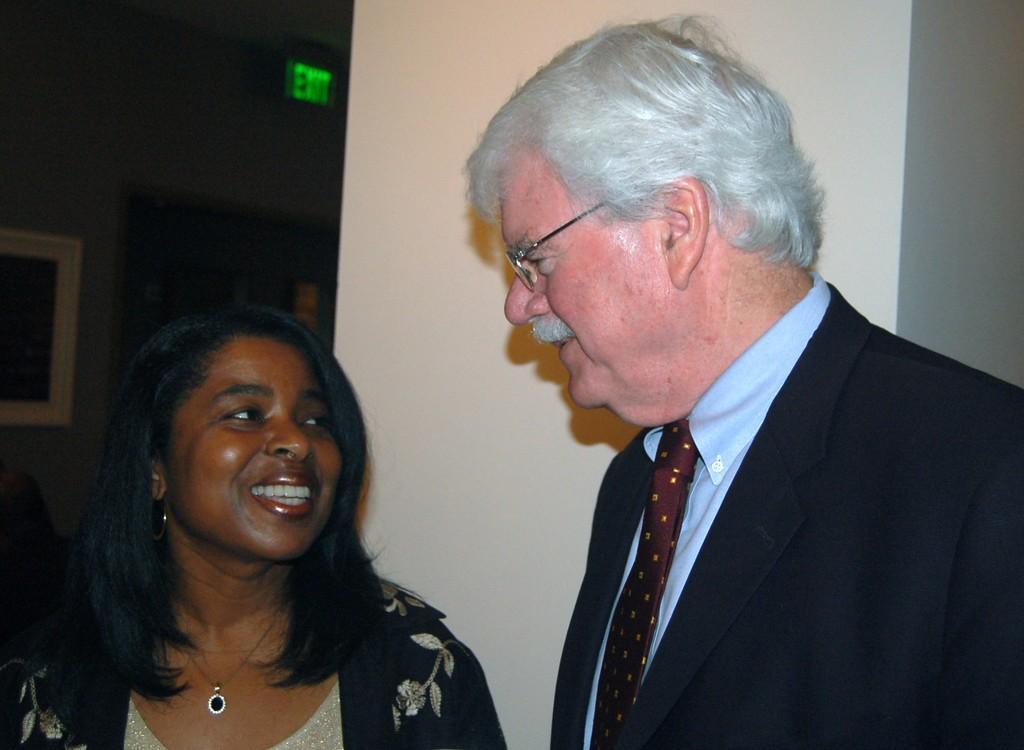Could you give a brief overview of what you see in this image? The man in blue shirt and black blazer who is wearing spectacles is standing beside the woman who is wearing black dress. Both of them are smiling. Behind them, we see a white pillar. Beside that, we see a photo frame which is placed on the wall. At the top of the picture, we see an exit board. In the background, it is black in color. 